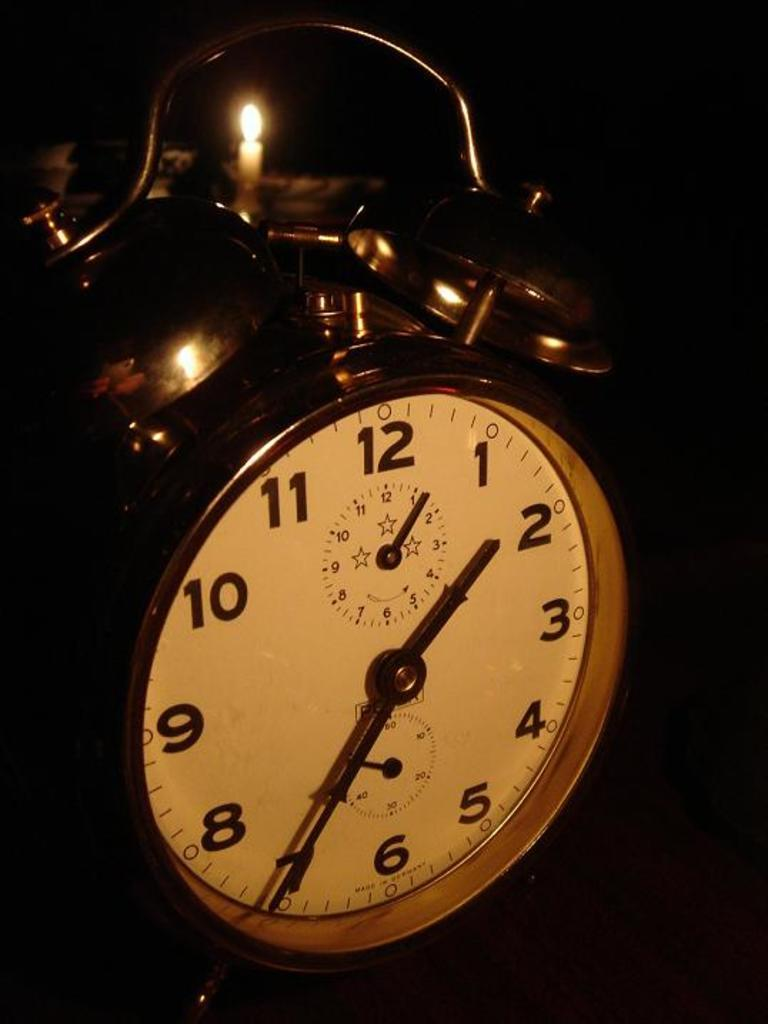What type of timekeeping device is present in the image? There is a timepiece clock in the image. What additional object can be seen in the image? There is a candle with light in the image. What type of cup is used to hold the candle in the image? There is no cup present in the image; the candle is not in a cup. How does the rail system function in the image? There is no rail system present in the image. 